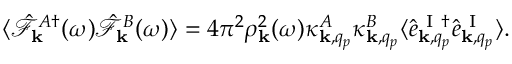Convert formula to latex. <formula><loc_0><loc_0><loc_500><loc_500>\begin{array} { r } { \langle \hat { \mathcal { F } } _ { k } ^ { A \dagger } ( \omega ) \hat { \mathcal { F } } _ { k } ^ { B } ( \omega ) \rangle = 4 \pi ^ { 2 } \rho _ { k } ^ { 2 } ( \omega ) \kappa _ { { k } , q _ { p } } ^ { A } \kappa _ { { k } , q _ { p } } ^ { B } \langle \hat { e } _ { { k } , q _ { p } } ^ { I \dagger } \hat { e } _ { { k } , q _ { p } } ^ { I } \rangle . } \end{array}</formula> 